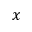<formula> <loc_0><loc_0><loc_500><loc_500>x</formula> 